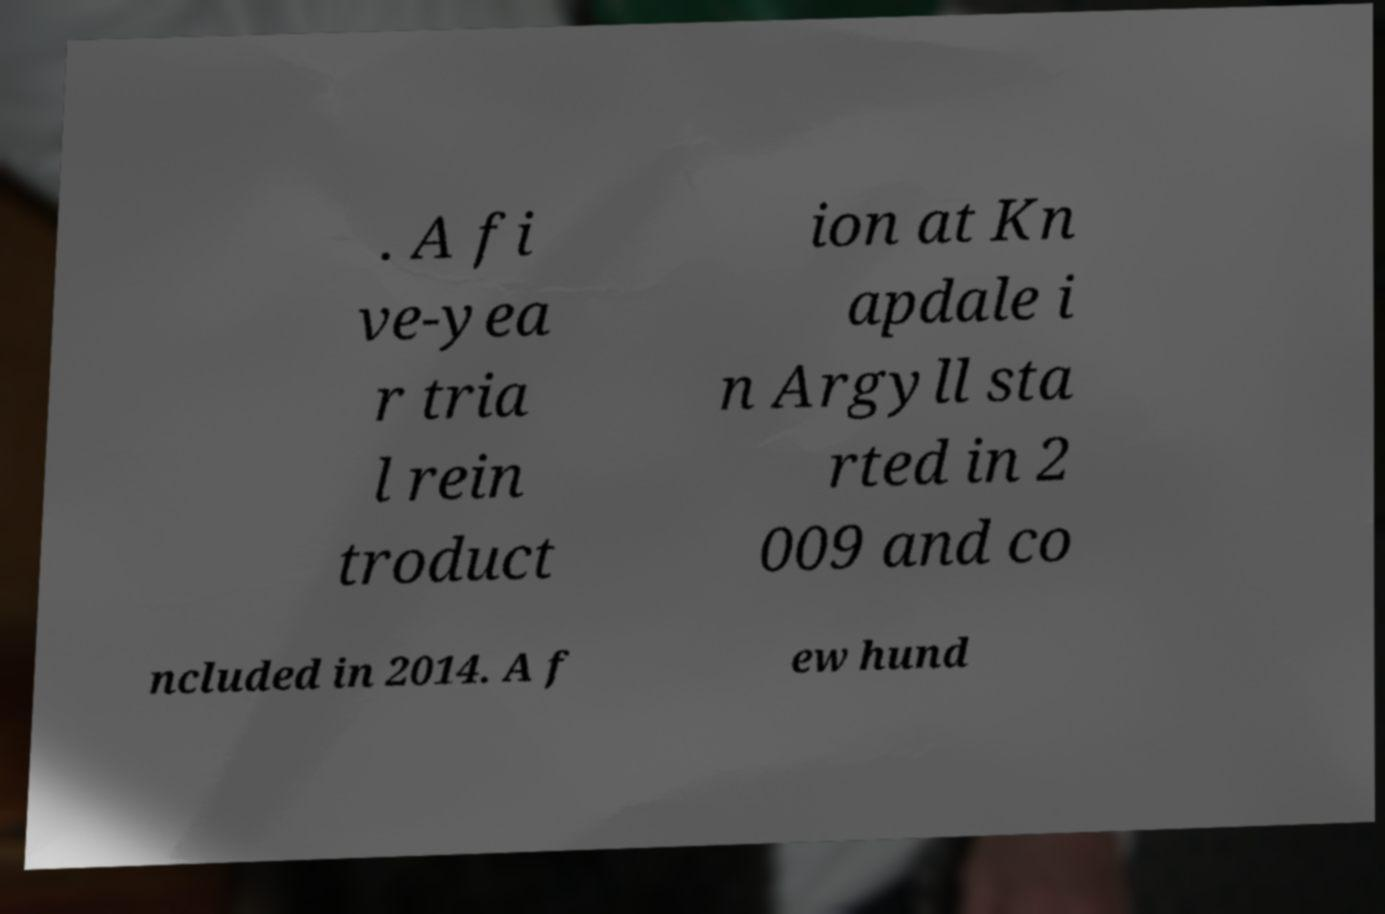I need the written content from this picture converted into text. Can you do that? . A fi ve-yea r tria l rein troduct ion at Kn apdale i n Argyll sta rted in 2 009 and co ncluded in 2014. A f ew hund 